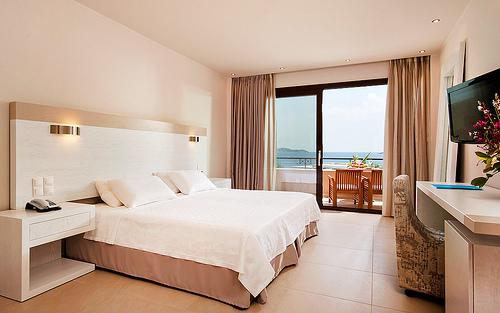Question: where was the picture taken from?
Choices:
A. Back yard.
B. Living room.
C. Bedroom.
D. In a house.
Answer with the letter. Answer: D Question: what is the color of the sheets?
Choices:
A. White.
B. Pink.
C. Yellow .
D. Blue.
Answer with the letter. Answer: A Question: who is in the room?
Choices:
A. No one.
B. She is.
C. His sister.
D. Her mother.
Answer with the letter. Answer: A Question: why are the lights on?
Choices:
A. To brighten the room.
B. To see.
C. To read.
D. To do homework.
Answer with the letter. Answer: A Question: how many people are in the room?
Choices:
A. Two.
B. Three.
C. None.
D. Four.
Answer with the letter. Answer: C 